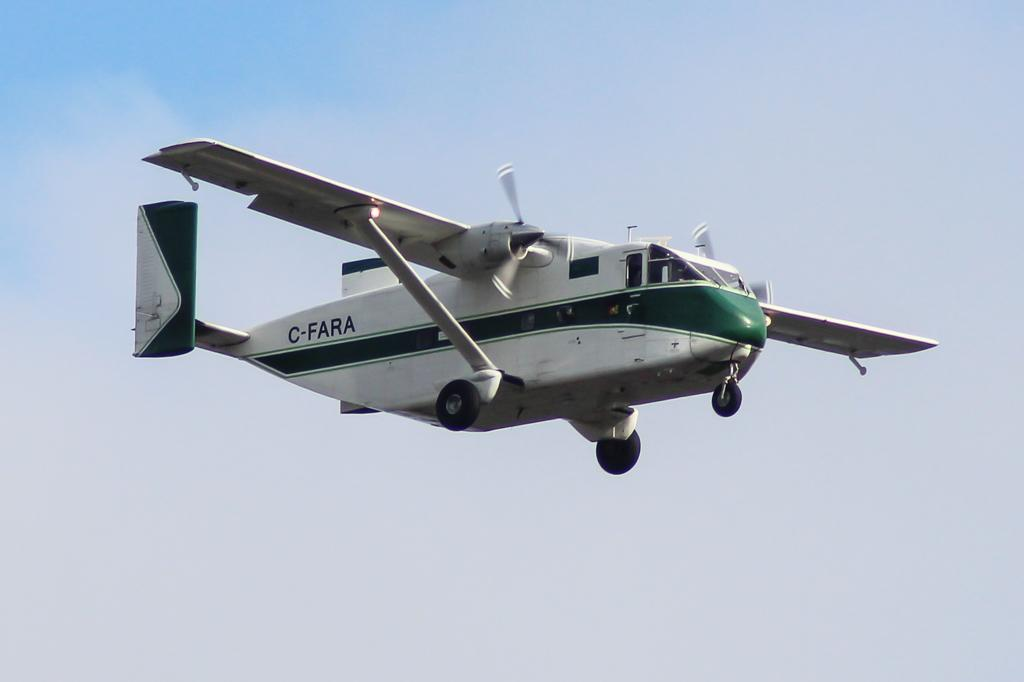<image>
Provide a brief description of the given image. A twin prop C-FARA plane is flying through the air. 